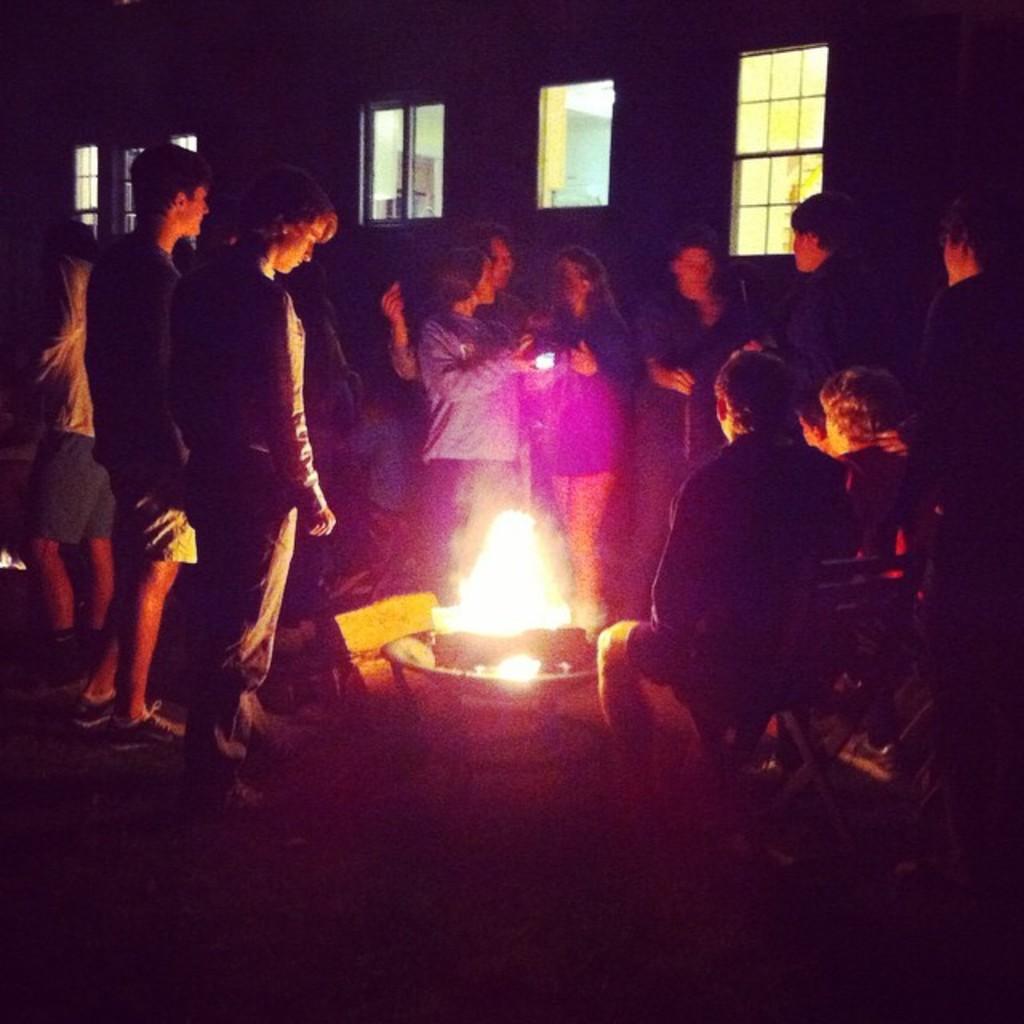In one or two sentences, can you explain what this image depicts? This is the picture of a room. In this image there are group of people standing and there are two persons sitting on the chairs. In the middle of the image there is a camp fire. At the back there are windows. 